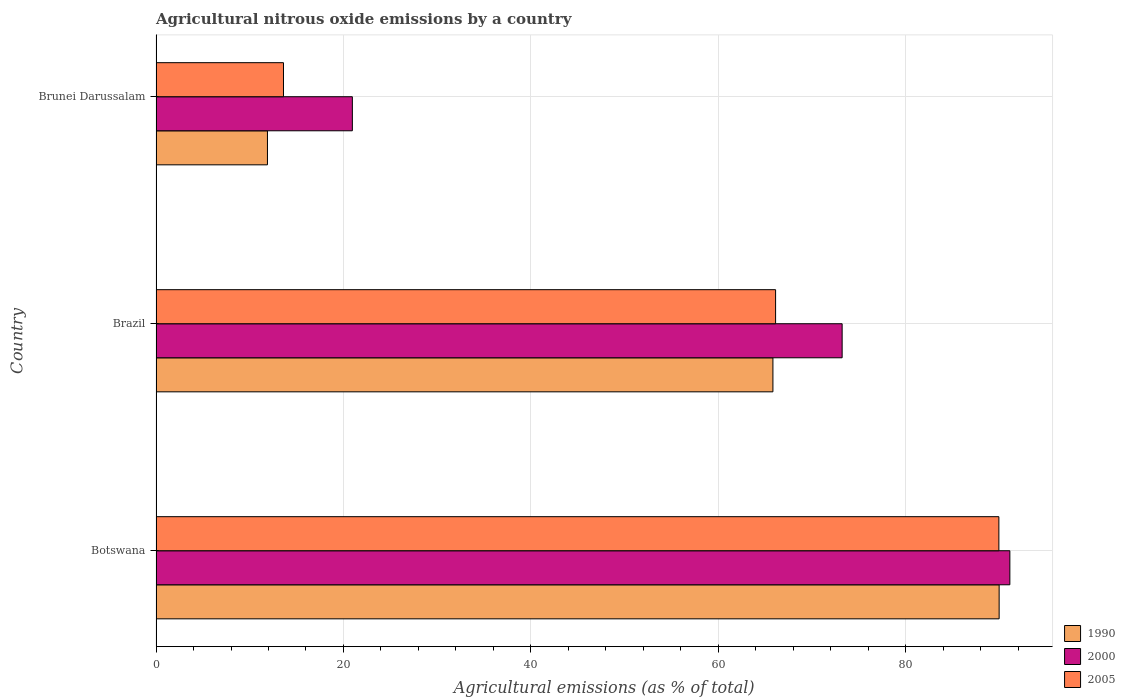How many different coloured bars are there?
Keep it short and to the point. 3. How many groups of bars are there?
Your answer should be compact. 3. Are the number of bars on each tick of the Y-axis equal?
Your response must be concise. Yes. How many bars are there on the 1st tick from the top?
Give a very brief answer. 3. How many bars are there on the 1st tick from the bottom?
Keep it short and to the point. 3. What is the label of the 3rd group of bars from the top?
Your answer should be very brief. Botswana. In how many cases, is the number of bars for a given country not equal to the number of legend labels?
Your answer should be very brief. 0. What is the amount of agricultural nitrous oxide emitted in 2000 in Brunei Darussalam?
Provide a short and direct response. 20.95. Across all countries, what is the maximum amount of agricultural nitrous oxide emitted in 2005?
Your answer should be compact. 89.93. Across all countries, what is the minimum amount of agricultural nitrous oxide emitted in 1990?
Make the answer very short. 11.89. In which country was the amount of agricultural nitrous oxide emitted in 1990 maximum?
Provide a short and direct response. Botswana. In which country was the amount of agricultural nitrous oxide emitted in 2000 minimum?
Your answer should be compact. Brunei Darussalam. What is the total amount of agricultural nitrous oxide emitted in 1990 in the graph?
Give a very brief answer. 167.67. What is the difference between the amount of agricultural nitrous oxide emitted in 2000 in Brazil and that in Brunei Darussalam?
Provide a short and direct response. 52.26. What is the difference between the amount of agricultural nitrous oxide emitted in 1990 in Brazil and the amount of agricultural nitrous oxide emitted in 2000 in Botswana?
Provide a succinct answer. -25.28. What is the average amount of agricultural nitrous oxide emitted in 2000 per country?
Give a very brief answer. 61.75. What is the difference between the amount of agricultural nitrous oxide emitted in 2000 and amount of agricultural nitrous oxide emitted in 2005 in Brazil?
Provide a succinct answer. 7.1. What is the ratio of the amount of agricultural nitrous oxide emitted in 1990 in Botswana to that in Brazil?
Offer a terse response. 1.37. Is the amount of agricultural nitrous oxide emitted in 1990 in Brazil less than that in Brunei Darussalam?
Make the answer very short. No. Is the difference between the amount of agricultural nitrous oxide emitted in 2000 in Botswana and Brunei Darussalam greater than the difference between the amount of agricultural nitrous oxide emitted in 2005 in Botswana and Brunei Darussalam?
Provide a short and direct response. No. What is the difference between the highest and the second highest amount of agricultural nitrous oxide emitted in 2005?
Make the answer very short. 23.82. What is the difference between the highest and the lowest amount of agricultural nitrous oxide emitted in 1990?
Give a very brief answer. 78.07. What does the 1st bar from the top in Brunei Darussalam represents?
Keep it short and to the point. 2005. What does the 3rd bar from the bottom in Botswana represents?
Provide a succinct answer. 2005. How many bars are there?
Your answer should be very brief. 9. Are all the bars in the graph horizontal?
Offer a very short reply. Yes. How many countries are there in the graph?
Keep it short and to the point. 3. Are the values on the major ticks of X-axis written in scientific E-notation?
Your response must be concise. No. How are the legend labels stacked?
Keep it short and to the point. Vertical. What is the title of the graph?
Make the answer very short. Agricultural nitrous oxide emissions by a country. Does "1983" appear as one of the legend labels in the graph?
Offer a very short reply. No. What is the label or title of the X-axis?
Keep it short and to the point. Agricultural emissions (as % of total). What is the Agricultural emissions (as % of total) in 1990 in Botswana?
Provide a succinct answer. 89.96. What is the Agricultural emissions (as % of total) of 2000 in Botswana?
Offer a very short reply. 91.1. What is the Agricultural emissions (as % of total) of 2005 in Botswana?
Give a very brief answer. 89.93. What is the Agricultural emissions (as % of total) in 1990 in Brazil?
Your answer should be very brief. 65.82. What is the Agricultural emissions (as % of total) of 2000 in Brazil?
Offer a terse response. 73.21. What is the Agricultural emissions (as % of total) in 2005 in Brazil?
Provide a short and direct response. 66.11. What is the Agricultural emissions (as % of total) of 1990 in Brunei Darussalam?
Your answer should be very brief. 11.89. What is the Agricultural emissions (as % of total) in 2000 in Brunei Darussalam?
Make the answer very short. 20.95. What is the Agricultural emissions (as % of total) in 2005 in Brunei Darussalam?
Keep it short and to the point. 13.6. Across all countries, what is the maximum Agricultural emissions (as % of total) of 1990?
Offer a very short reply. 89.96. Across all countries, what is the maximum Agricultural emissions (as % of total) of 2000?
Give a very brief answer. 91.1. Across all countries, what is the maximum Agricultural emissions (as % of total) in 2005?
Make the answer very short. 89.93. Across all countries, what is the minimum Agricultural emissions (as % of total) of 1990?
Your response must be concise. 11.89. Across all countries, what is the minimum Agricultural emissions (as % of total) in 2000?
Provide a succinct answer. 20.95. Across all countries, what is the minimum Agricultural emissions (as % of total) in 2005?
Offer a terse response. 13.6. What is the total Agricultural emissions (as % of total) in 1990 in the graph?
Your answer should be very brief. 167.67. What is the total Agricultural emissions (as % of total) in 2000 in the graph?
Provide a short and direct response. 185.25. What is the total Agricultural emissions (as % of total) in 2005 in the graph?
Ensure brevity in your answer.  169.63. What is the difference between the Agricultural emissions (as % of total) of 1990 in Botswana and that in Brazil?
Offer a very short reply. 24.14. What is the difference between the Agricultural emissions (as % of total) in 2000 in Botswana and that in Brazil?
Ensure brevity in your answer.  17.89. What is the difference between the Agricultural emissions (as % of total) in 2005 in Botswana and that in Brazil?
Provide a succinct answer. 23.82. What is the difference between the Agricultural emissions (as % of total) of 1990 in Botswana and that in Brunei Darussalam?
Make the answer very short. 78.07. What is the difference between the Agricultural emissions (as % of total) of 2000 in Botswana and that in Brunei Darussalam?
Make the answer very short. 70.15. What is the difference between the Agricultural emissions (as % of total) in 2005 in Botswana and that in Brunei Darussalam?
Your answer should be very brief. 76.33. What is the difference between the Agricultural emissions (as % of total) in 1990 in Brazil and that in Brunei Darussalam?
Provide a succinct answer. 53.93. What is the difference between the Agricultural emissions (as % of total) of 2000 in Brazil and that in Brunei Darussalam?
Make the answer very short. 52.26. What is the difference between the Agricultural emissions (as % of total) in 2005 in Brazil and that in Brunei Darussalam?
Your answer should be very brief. 52.51. What is the difference between the Agricultural emissions (as % of total) in 1990 in Botswana and the Agricultural emissions (as % of total) in 2000 in Brazil?
Your answer should be compact. 16.75. What is the difference between the Agricultural emissions (as % of total) of 1990 in Botswana and the Agricultural emissions (as % of total) of 2005 in Brazil?
Your answer should be very brief. 23.85. What is the difference between the Agricultural emissions (as % of total) of 2000 in Botswana and the Agricultural emissions (as % of total) of 2005 in Brazil?
Provide a succinct answer. 24.99. What is the difference between the Agricultural emissions (as % of total) of 1990 in Botswana and the Agricultural emissions (as % of total) of 2000 in Brunei Darussalam?
Give a very brief answer. 69.01. What is the difference between the Agricultural emissions (as % of total) of 1990 in Botswana and the Agricultural emissions (as % of total) of 2005 in Brunei Darussalam?
Your response must be concise. 76.36. What is the difference between the Agricultural emissions (as % of total) of 2000 in Botswana and the Agricultural emissions (as % of total) of 2005 in Brunei Darussalam?
Offer a very short reply. 77.5. What is the difference between the Agricultural emissions (as % of total) in 1990 in Brazil and the Agricultural emissions (as % of total) in 2000 in Brunei Darussalam?
Keep it short and to the point. 44.87. What is the difference between the Agricultural emissions (as % of total) of 1990 in Brazil and the Agricultural emissions (as % of total) of 2005 in Brunei Darussalam?
Provide a succinct answer. 52.22. What is the difference between the Agricultural emissions (as % of total) in 2000 in Brazil and the Agricultural emissions (as % of total) in 2005 in Brunei Darussalam?
Make the answer very short. 59.61. What is the average Agricultural emissions (as % of total) in 1990 per country?
Make the answer very short. 55.89. What is the average Agricultural emissions (as % of total) of 2000 per country?
Keep it short and to the point. 61.75. What is the average Agricultural emissions (as % of total) in 2005 per country?
Give a very brief answer. 56.54. What is the difference between the Agricultural emissions (as % of total) of 1990 and Agricultural emissions (as % of total) of 2000 in Botswana?
Your response must be concise. -1.14. What is the difference between the Agricultural emissions (as % of total) of 1990 and Agricultural emissions (as % of total) of 2005 in Botswana?
Keep it short and to the point. 0.03. What is the difference between the Agricultural emissions (as % of total) in 2000 and Agricultural emissions (as % of total) in 2005 in Botswana?
Make the answer very short. 1.17. What is the difference between the Agricultural emissions (as % of total) of 1990 and Agricultural emissions (as % of total) of 2000 in Brazil?
Provide a succinct answer. -7.39. What is the difference between the Agricultural emissions (as % of total) of 1990 and Agricultural emissions (as % of total) of 2005 in Brazil?
Make the answer very short. -0.29. What is the difference between the Agricultural emissions (as % of total) of 2000 and Agricultural emissions (as % of total) of 2005 in Brazil?
Provide a succinct answer. 7.1. What is the difference between the Agricultural emissions (as % of total) of 1990 and Agricultural emissions (as % of total) of 2000 in Brunei Darussalam?
Your answer should be compact. -9.06. What is the difference between the Agricultural emissions (as % of total) of 1990 and Agricultural emissions (as % of total) of 2005 in Brunei Darussalam?
Make the answer very short. -1.71. What is the difference between the Agricultural emissions (as % of total) of 2000 and Agricultural emissions (as % of total) of 2005 in Brunei Darussalam?
Your answer should be very brief. 7.35. What is the ratio of the Agricultural emissions (as % of total) in 1990 in Botswana to that in Brazil?
Your answer should be very brief. 1.37. What is the ratio of the Agricultural emissions (as % of total) of 2000 in Botswana to that in Brazil?
Make the answer very short. 1.24. What is the ratio of the Agricultural emissions (as % of total) of 2005 in Botswana to that in Brazil?
Your response must be concise. 1.36. What is the ratio of the Agricultural emissions (as % of total) of 1990 in Botswana to that in Brunei Darussalam?
Your answer should be very brief. 7.57. What is the ratio of the Agricultural emissions (as % of total) in 2000 in Botswana to that in Brunei Darussalam?
Your answer should be very brief. 4.35. What is the ratio of the Agricultural emissions (as % of total) of 2005 in Botswana to that in Brunei Darussalam?
Ensure brevity in your answer.  6.61. What is the ratio of the Agricultural emissions (as % of total) in 1990 in Brazil to that in Brunei Darussalam?
Offer a very short reply. 5.54. What is the ratio of the Agricultural emissions (as % of total) in 2000 in Brazil to that in Brunei Darussalam?
Provide a succinct answer. 3.49. What is the ratio of the Agricultural emissions (as % of total) of 2005 in Brazil to that in Brunei Darussalam?
Provide a short and direct response. 4.86. What is the difference between the highest and the second highest Agricultural emissions (as % of total) in 1990?
Your answer should be compact. 24.14. What is the difference between the highest and the second highest Agricultural emissions (as % of total) in 2000?
Your answer should be very brief. 17.89. What is the difference between the highest and the second highest Agricultural emissions (as % of total) of 2005?
Offer a very short reply. 23.82. What is the difference between the highest and the lowest Agricultural emissions (as % of total) in 1990?
Offer a very short reply. 78.07. What is the difference between the highest and the lowest Agricultural emissions (as % of total) of 2000?
Provide a short and direct response. 70.15. What is the difference between the highest and the lowest Agricultural emissions (as % of total) in 2005?
Your response must be concise. 76.33. 